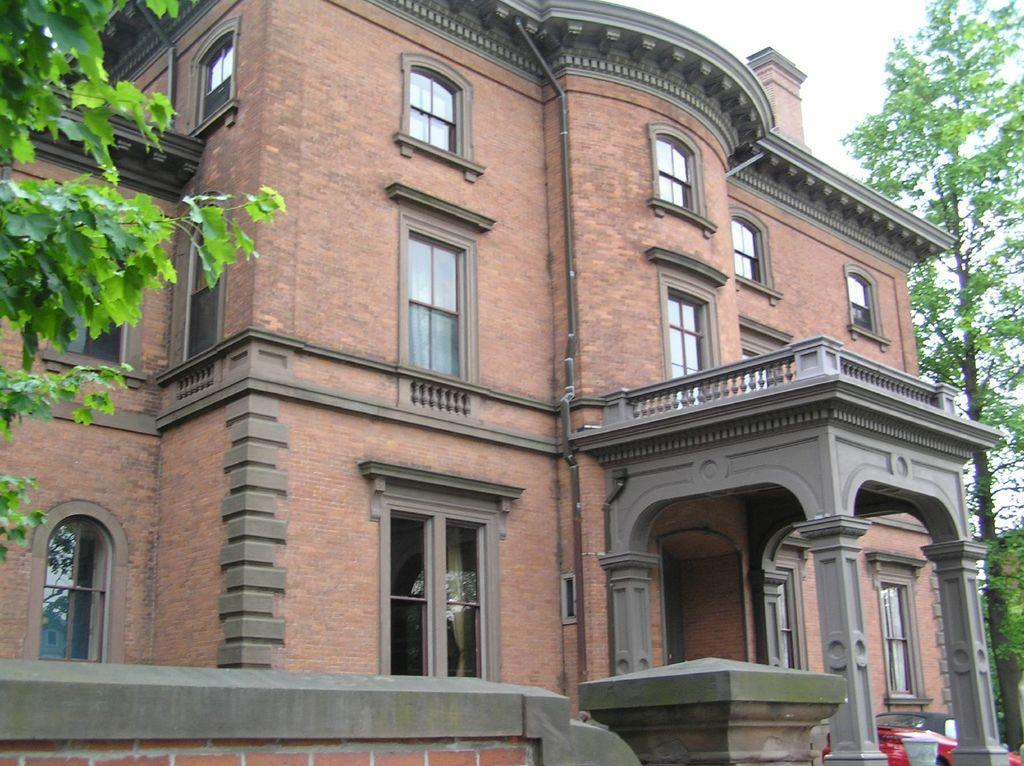What type of building is in the image? There is a brown building with a glass window in the image. What is parked near the building? A red car is parked in the portico of the building. What kind of vegetation is present in the image? There is a tree with leaves visible in the image. How many pies are on the tree in the image? There are no pies present in the image; it features a tree with leaves. What type of quill is used to write on the glass window? There is no quill present in the image, and the glass window is not being written on. 